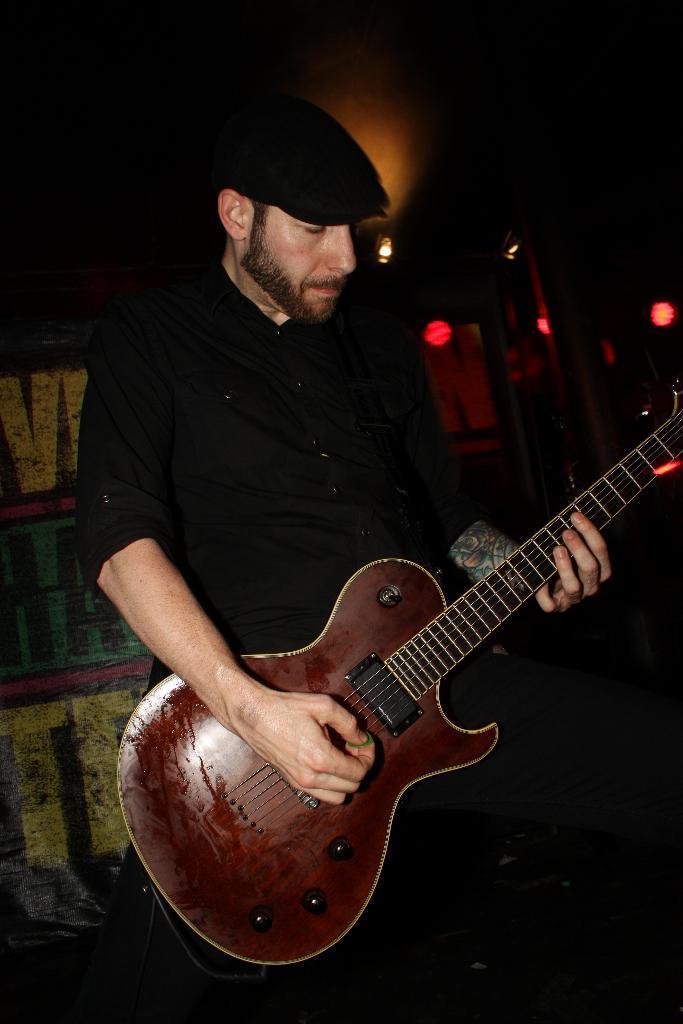Could you give a brief overview of what you see in this image? There is a man standing with a guitar in his hand and a cap on his head and the man is playing the guitar,in the background we can see lights and a wall. 